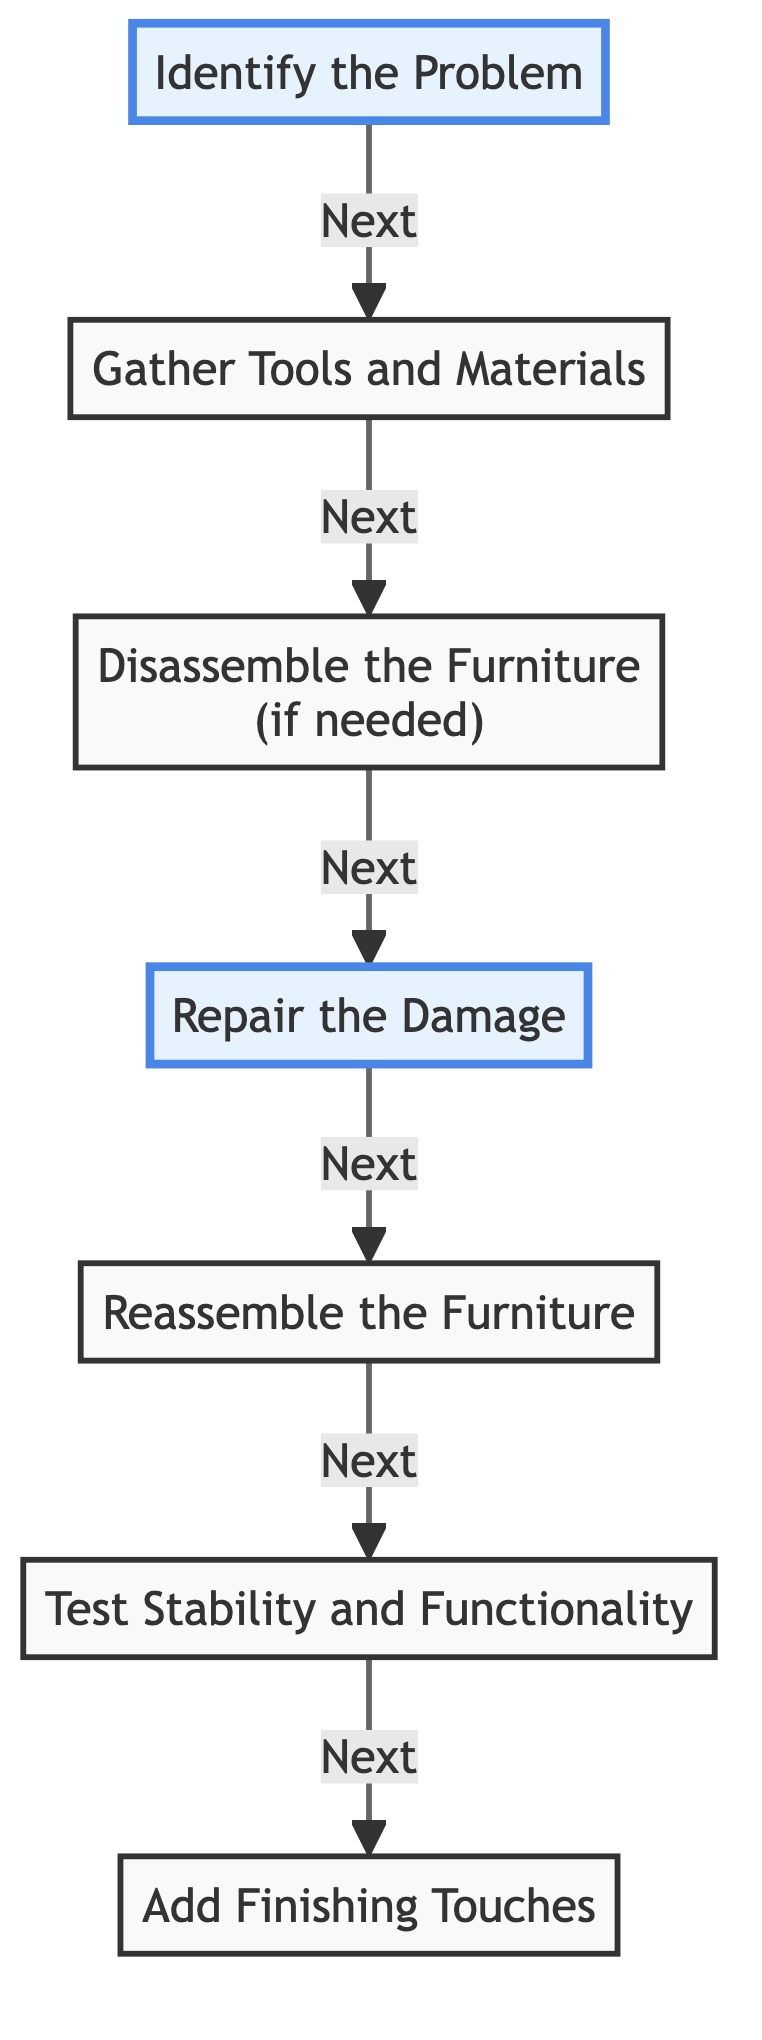What is the first step in the workflow? The first step is represented by the node labeled "Identify the Problem". This is the starting point of the flow chart where the assessment of the furniture piece occurs.
Answer: Identify the Problem How many main steps are there in the diagram? The diagram consists of a total of seven steps, including identifying the problem and adding finishing touches. Each step represents a specific action in the workflow.
Answer: Seven What action happens after testing stability? After "Test Stability and Functionality", the next action is "Add Finishing Touches". This indicates that finishing touches come after ensuring the repair is stable.
Answer: Add Finishing Touches What are the tools and materials gathered in the second step? The second step indicates the need to gather "Tools and Materials". This means collecting necessary tools and repair materials for fixing the furniture.
Answer: Tools and Materials If a piece of furniture needs to be taken apart, what is the next step? If disassembly is needed, the flow indicates to follow from "Disassemble the Furniture" to "Repair the Damage". This shows the necessary progression to address the issue.
Answer: Repair the Damage Which step directly precedes gathering tools? The step that directly precedes "Gather Tools and Materials" is "Identify the Problem". This establishes a sequence where identifying the issue leads to the gathering needed for the repair.
Answer: Identify the Problem What is the primary purpose of the "Repair the Damage" step? The purpose of "Repair the Damage" is to fix issues with the furniture piece using appropriate methods. It is a critical step that focuses on correcting the identified problem.
Answer: Fix issues What does the term "Reassemble the Furniture" imply in this context? "Reassemble the Furniture" implies putting the furniture back together carefully after repairs have been made, ensuring all parts are secure.
Answer: Put the furniture back together What indicates the end of the workflow in the diagram? The end of the workflow is indicated by the last step, "Add Finishing Touches". This marks the conclusion of the repair process with necessary aesthetic improvements.
Answer: Add Finishing Touches 